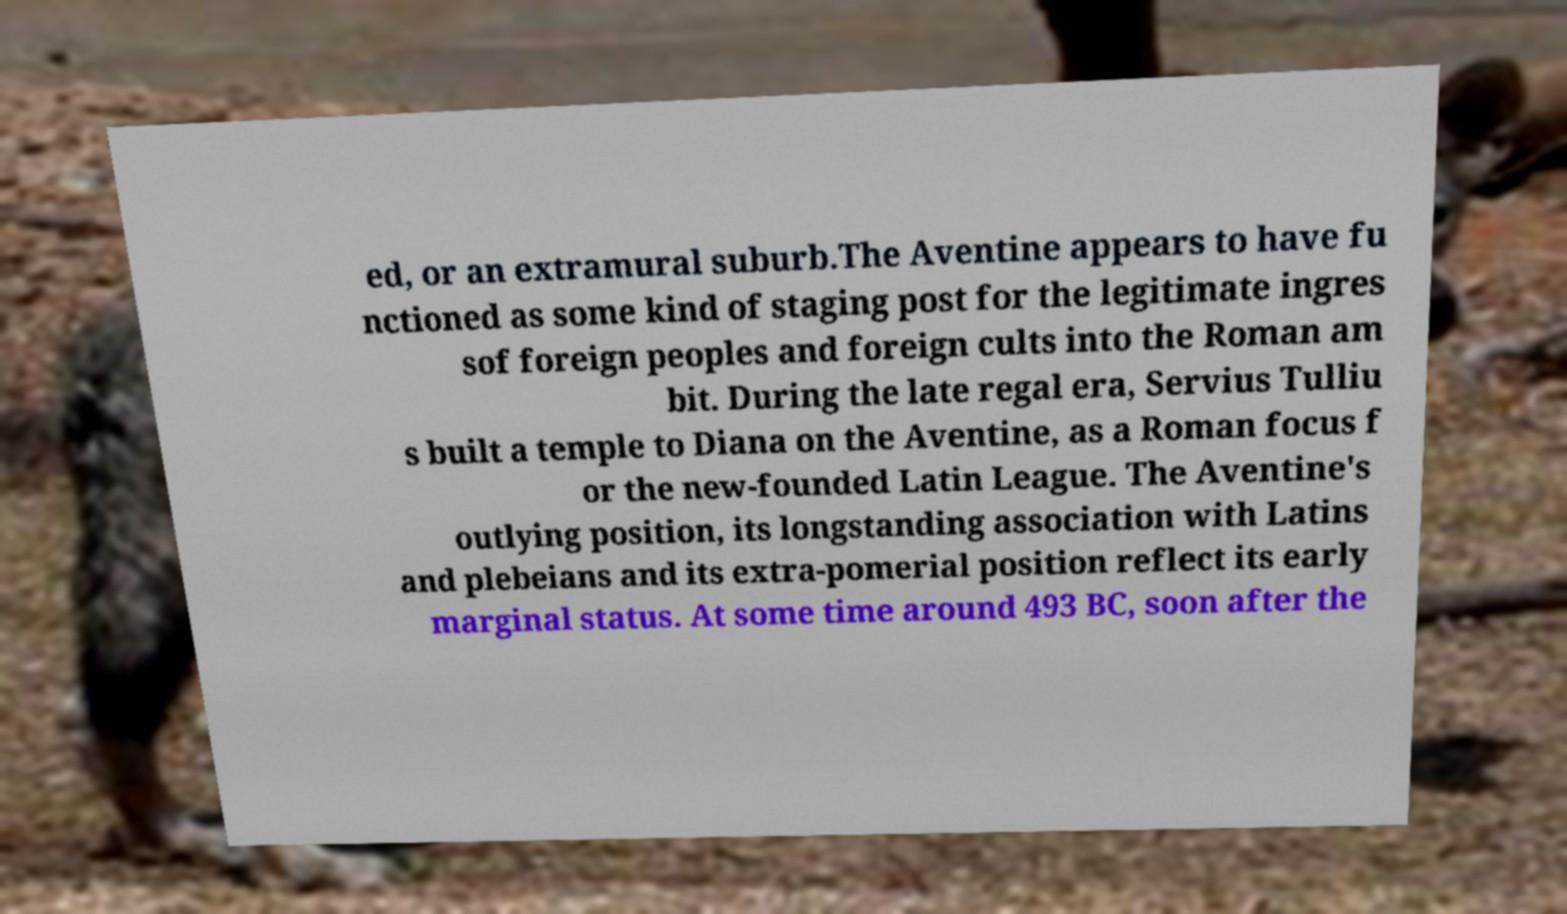Please identify and transcribe the text found in this image. ed, or an extramural suburb.The Aventine appears to have fu nctioned as some kind of staging post for the legitimate ingres sof foreign peoples and foreign cults into the Roman am bit. During the late regal era, Servius Tulliu s built a temple to Diana on the Aventine, as a Roman focus f or the new-founded Latin League. The Aventine's outlying position, its longstanding association with Latins and plebeians and its extra-pomerial position reflect its early marginal status. At some time around 493 BC, soon after the 